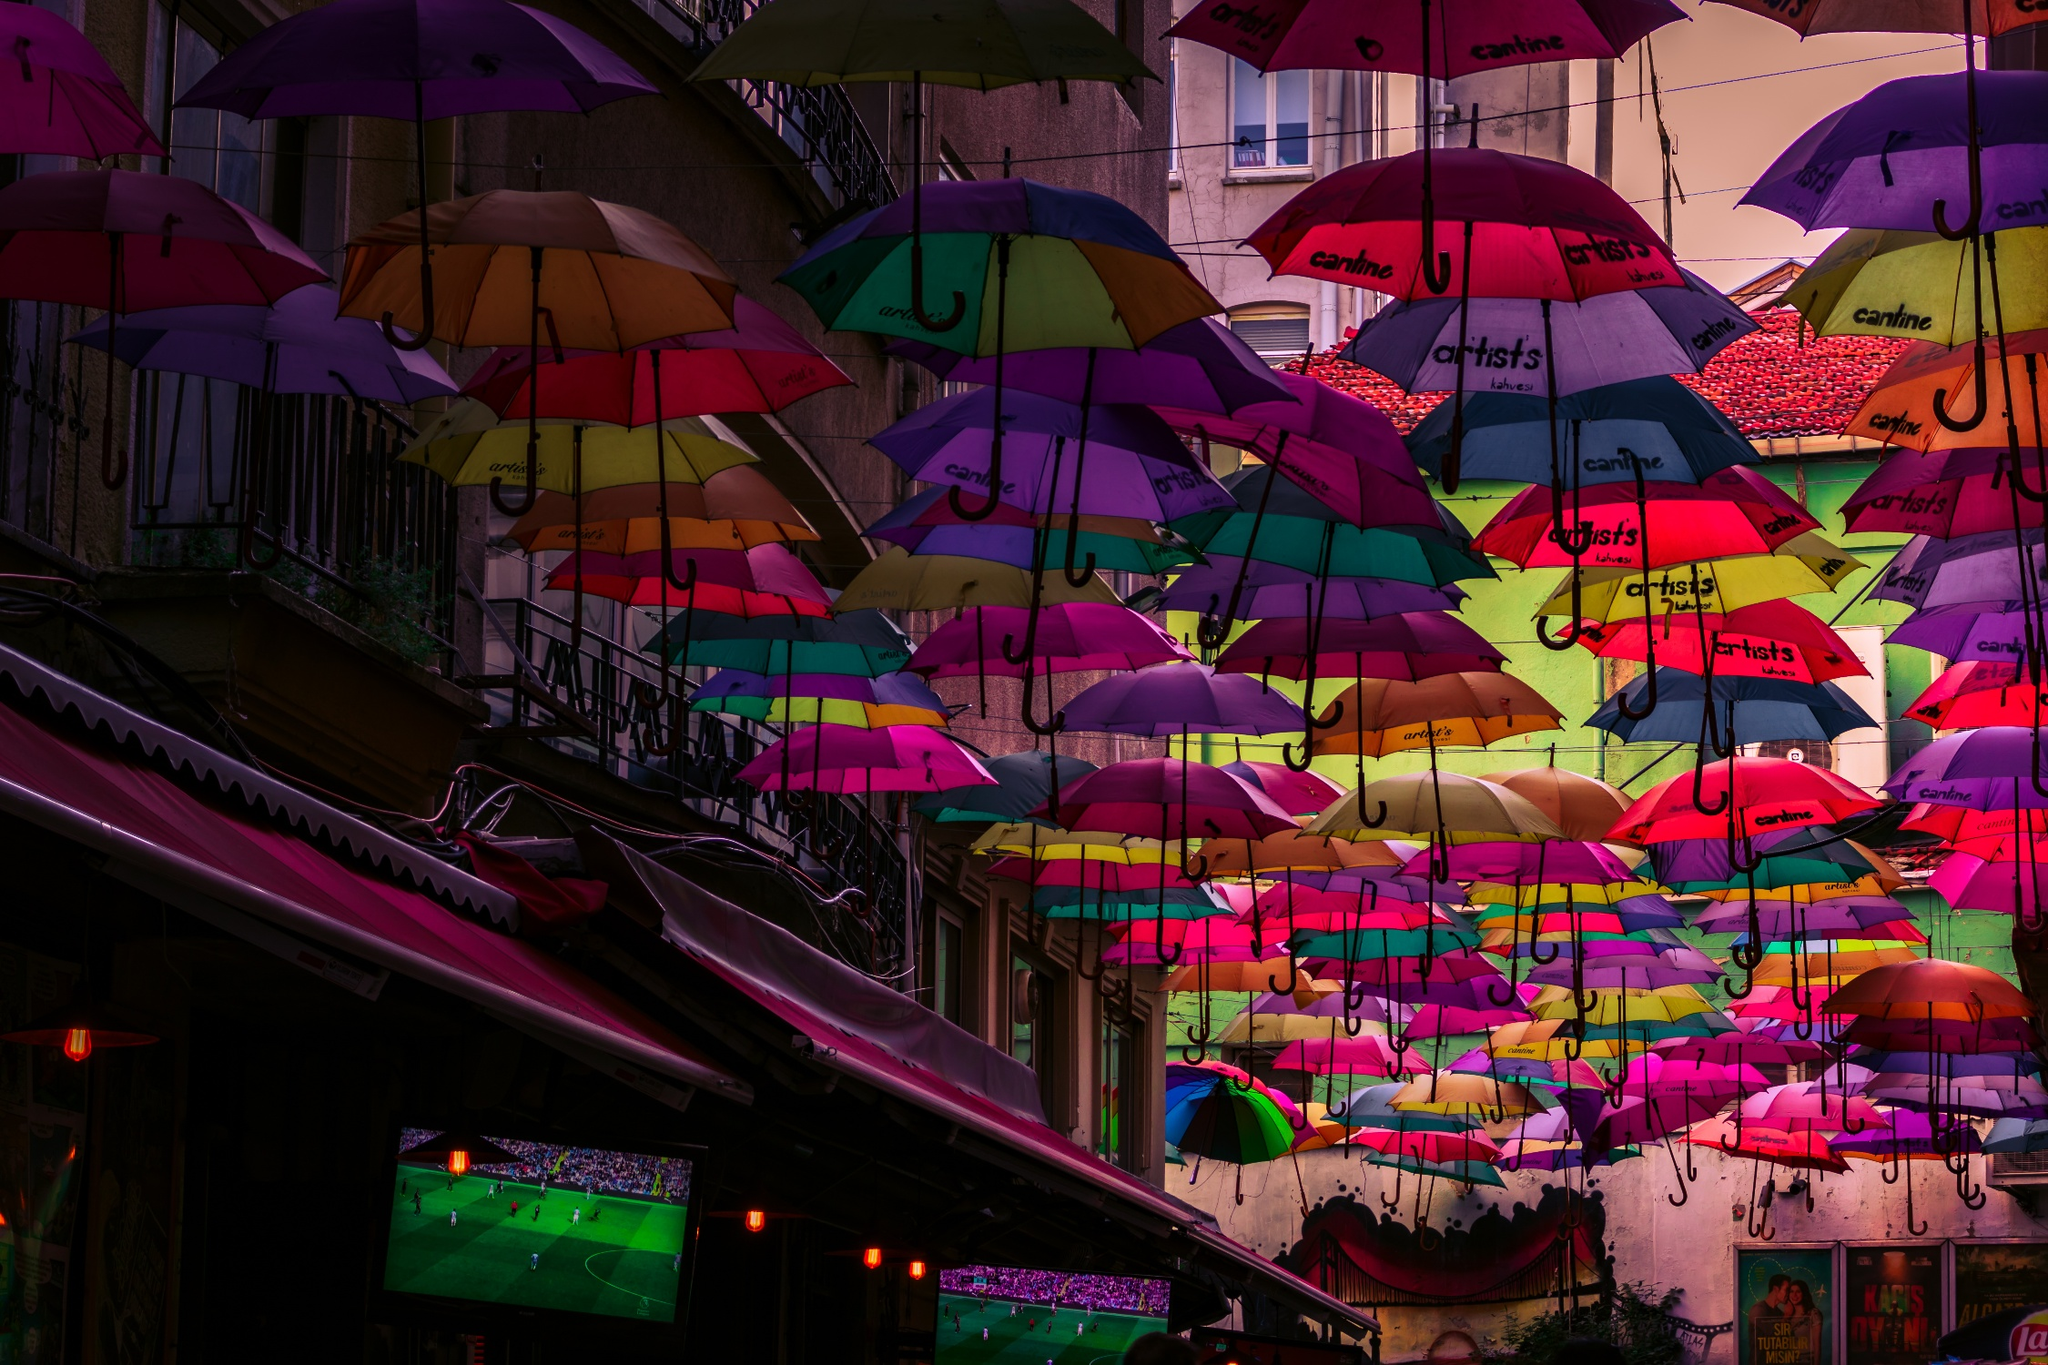What might a day in this place look like during a festival? During a festival, a day in this place would likely be brimming with activities and joy. The morning could start with street performers and musicians setting up, their melodies intertwining with the murmur of early visitors. Stalls selling local crafts, food, and drinks would line the streets, the aroma of street food mingling with the fresh morning breeze. As the day progresses, workshops and interactive art sessions might engage children and adults alike, turning the streets into a lively educational space. By afternoon, the area would be buzzing with life; people would be taking photos, mingling, and enjoying street theater performances. As evening falls, colorful lights strung among the umbrellas would create a magical ambiance. Outdoor dining would flourish under the canopy of umbrellas, while local bands and DJs take the stage, filling the night with music and dance. Fireworks or light shows might cap off the day, leaving participants with memories of a vibrant, community-centered celebration. 